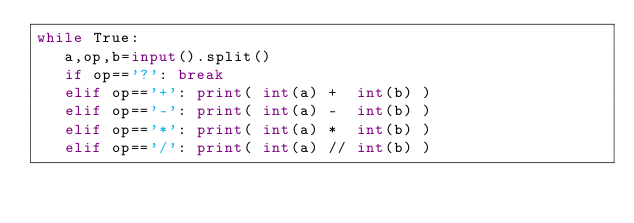Convert code to text. <code><loc_0><loc_0><loc_500><loc_500><_Python_>while True:
   a,op,b=input().split()
   if op=='?': break
   elif op=='+': print( int(a) +  int(b) )
   elif op=='-': print( int(a) -  int(b) )
   elif op=='*': print( int(a) *  int(b) )
   elif op=='/': print( int(a) // int(b) )
</code> 